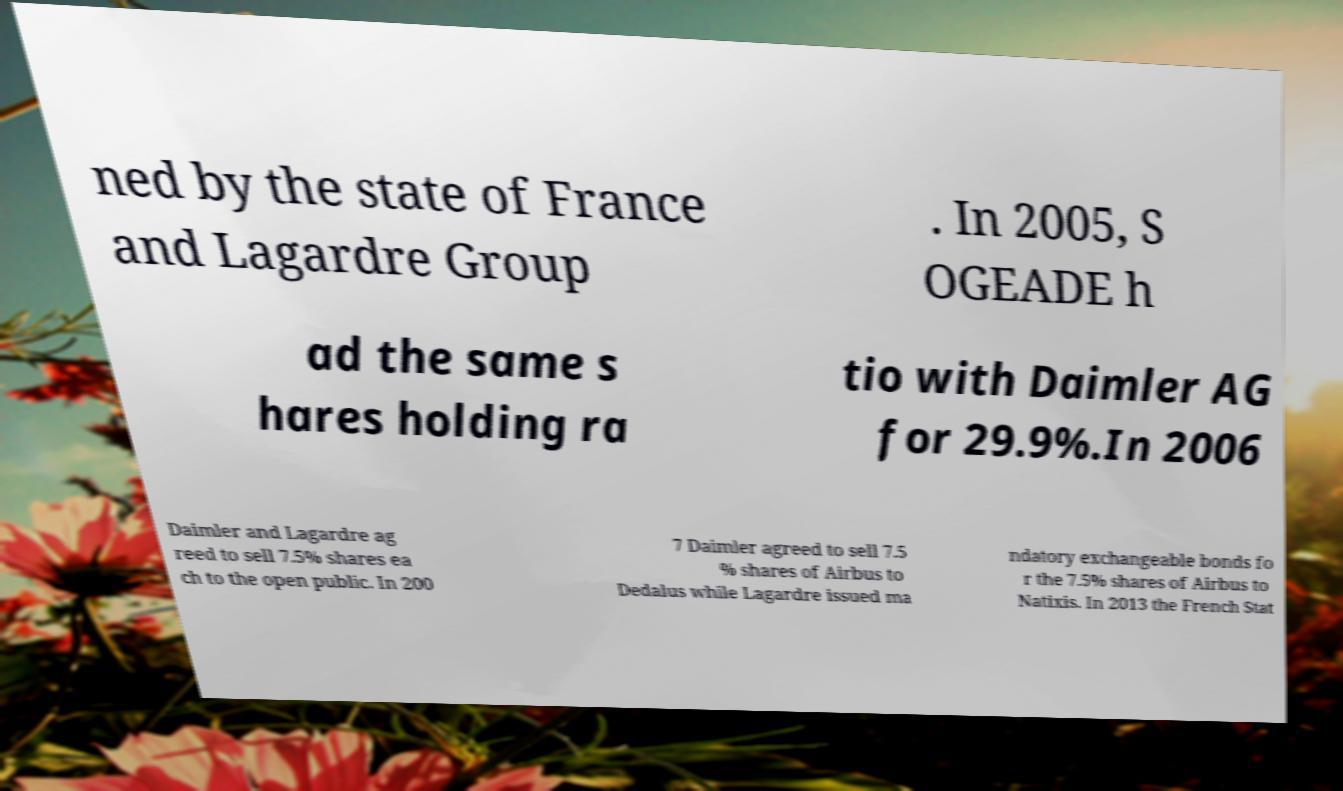Please read and relay the text visible in this image. What does it say? ned by the state of France and Lagardre Group . In 2005, S OGEADE h ad the same s hares holding ra tio with Daimler AG for 29.9%.In 2006 Daimler and Lagardre ag reed to sell 7.5% shares ea ch to the open public. In 200 7 Daimler agreed to sell 7.5 % shares of Airbus to Dedalus while Lagardre issued ma ndatory exchangeable bonds fo r the 7.5% shares of Airbus to Natixis. In 2013 the French Stat 